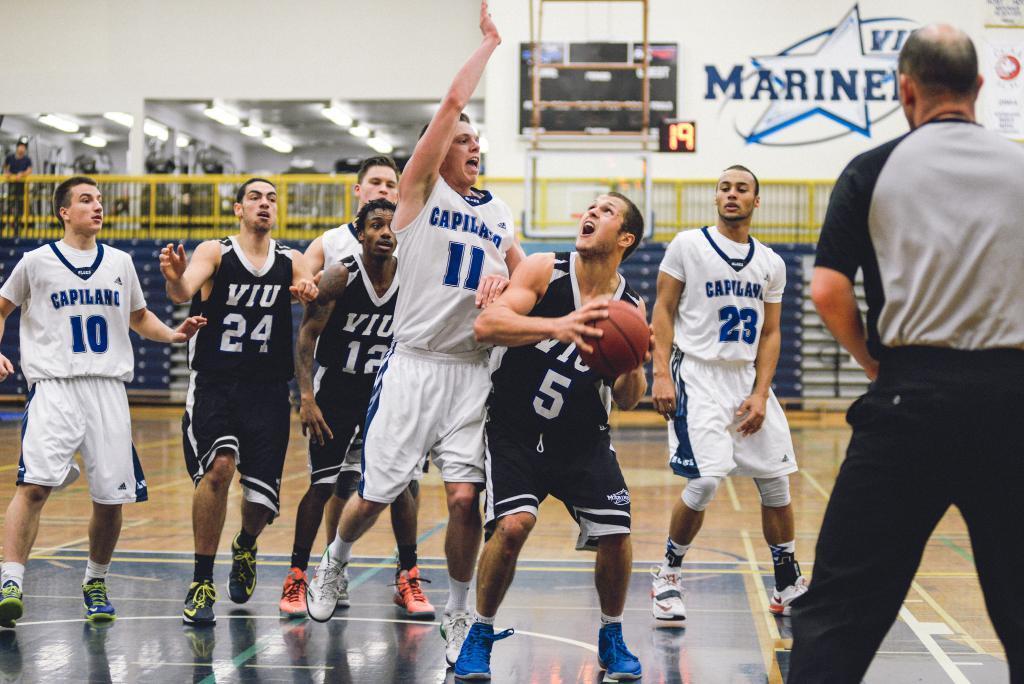How would you summarize this image in a sentence or two? In this picture we can see a group of people standing on the ground,one person is holding a ball and in the background we can see a fence,wall. 